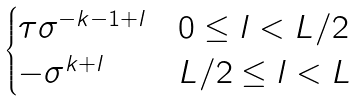<formula> <loc_0><loc_0><loc_500><loc_500>\begin{cases} \tau \sigma ^ { - k - 1 + l } & 0 \leq l < L / 2 \\ - \sigma ^ { k + l } & L / 2 \leq l < L \end{cases}</formula> 